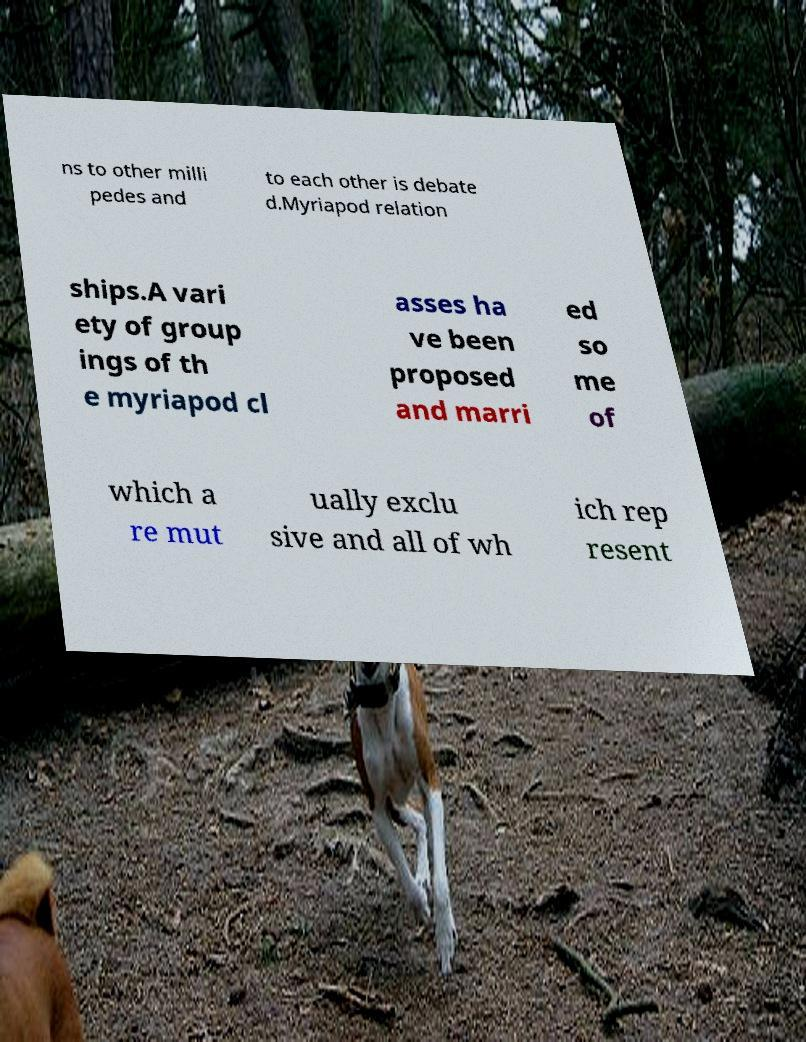Can you accurately transcribe the text from the provided image for me? ns to other milli pedes and to each other is debate d.Myriapod relation ships.A vari ety of group ings of th e myriapod cl asses ha ve been proposed and marri ed so me of which a re mut ually exclu sive and all of wh ich rep resent 